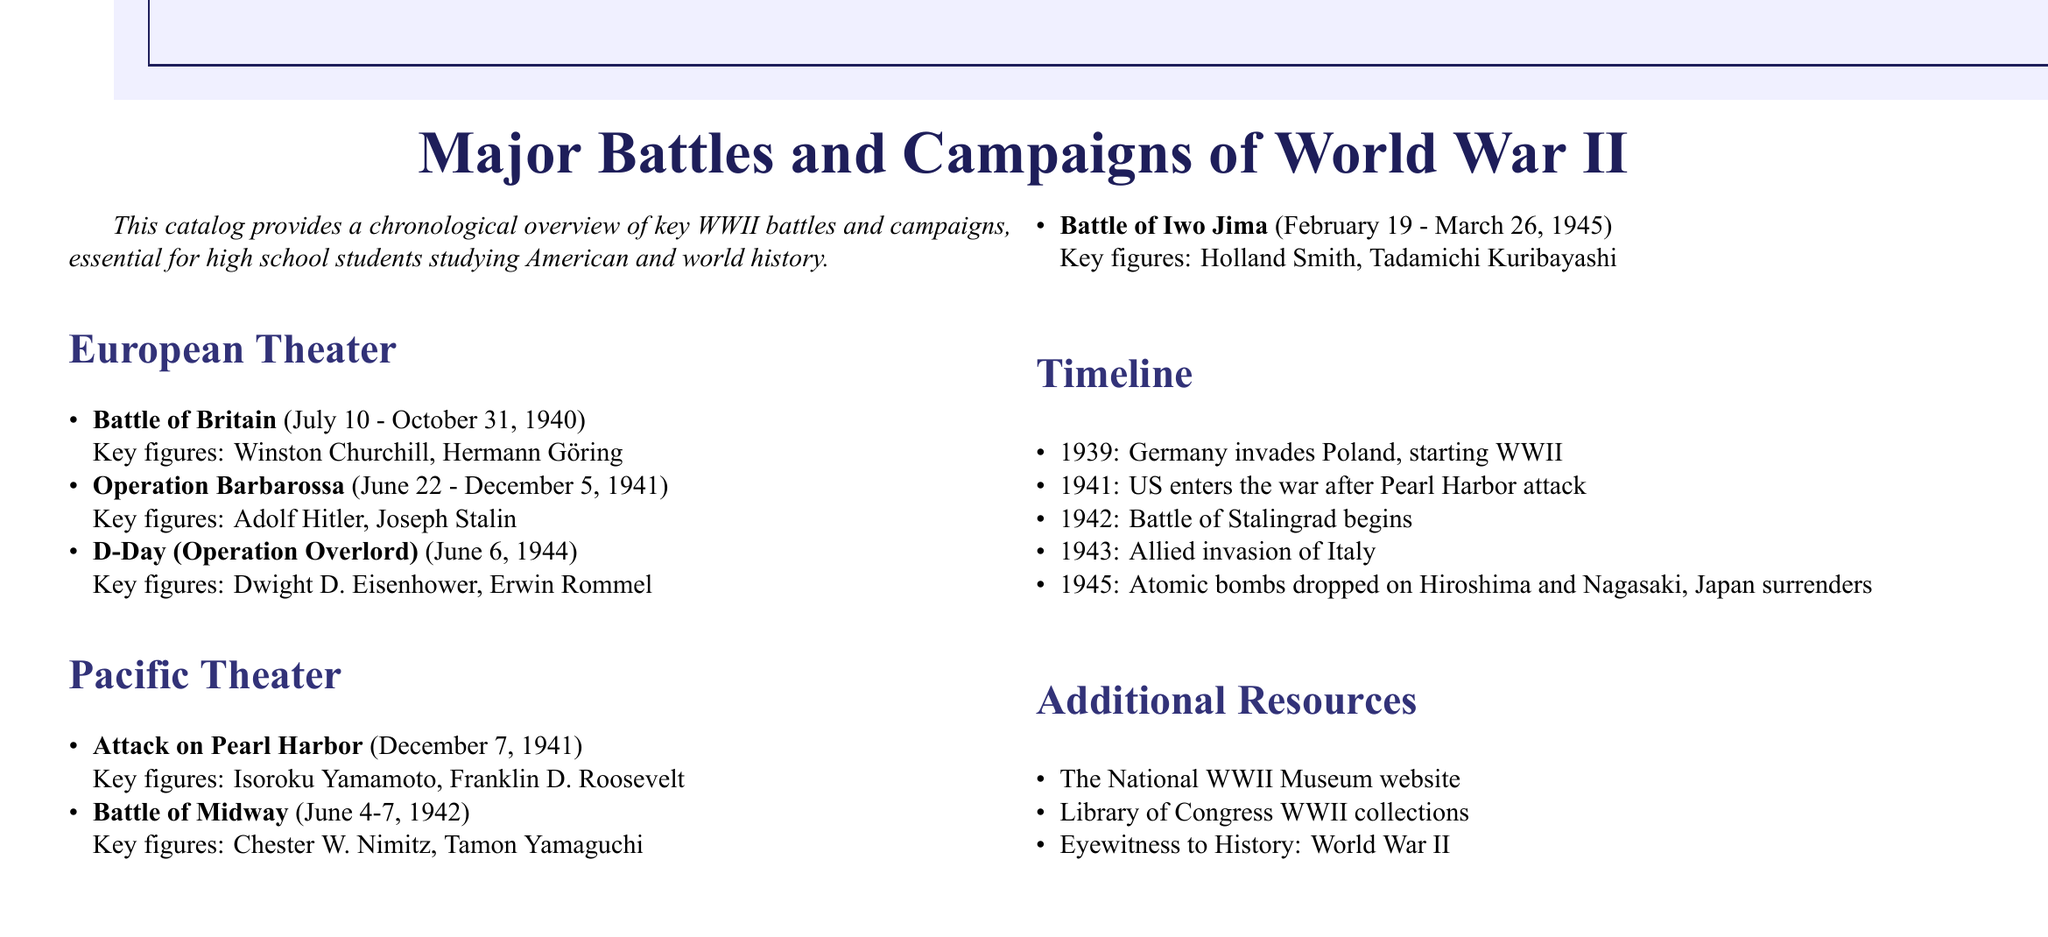What is the title of the catalog? The title of the catalog is presented prominently at the beginning, indicating its focus on significant events of WWII.
Answer: Major Battles and Campaigns of World War II When did the Battle of Britain occur? The Battle of Britain is noted with its specific start and end dates listed in the document.
Answer: July 10 - October 31, 1940 Who were the key figures in the Battle of Midway? The document lists key figures associated with each battle, identifying important leaders involved.
Answer: Chester W. Nimitz, Tamon Yamaguchi What significant event happened in 1941? A pivotal timeline event is noted for the year 1941, highlighting the United States' entry into the war.
Answer: US enters the war after Pearl Harbor attack Which battle started on June 6, 1944? The document gives specific battles matched with their corresponding dates, allowing identification of battles by date.
Answer: D-Day (Operation Overlord) How many battles are listed in the European Theater section? The document enumerates the battles listed in each section, allowing a count of the battles.
Answer: 3 Who was the key figure for the Attack on Pearl Harbor? Each event mentions notable figures and their association with the respective battles or events.
Answer: Isoroku Yamamoto What is one additional resource mentioned in the catalog? Additional resources are listed for further study, one of which can be cited as specified in the document.
Answer: The National WWII Museum website What year did the Battle of Stalingrad begin? The timeline provides a list of critical events and their dates throughout the war.
Answer: 1942 